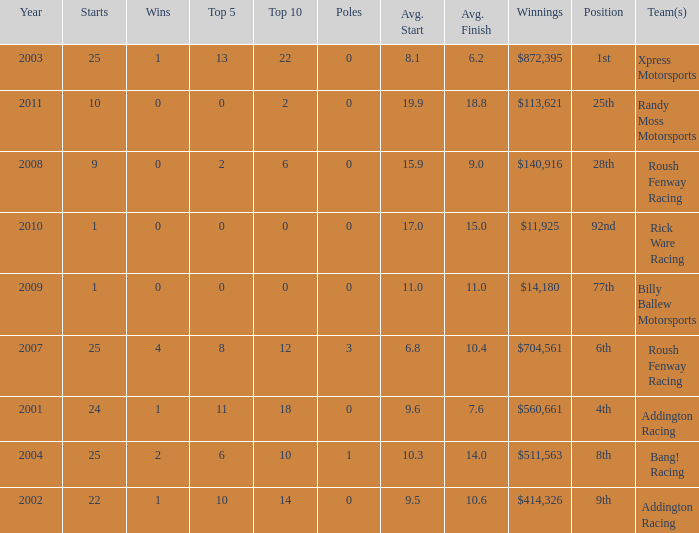How many wins in the 4th position? 1.0. 